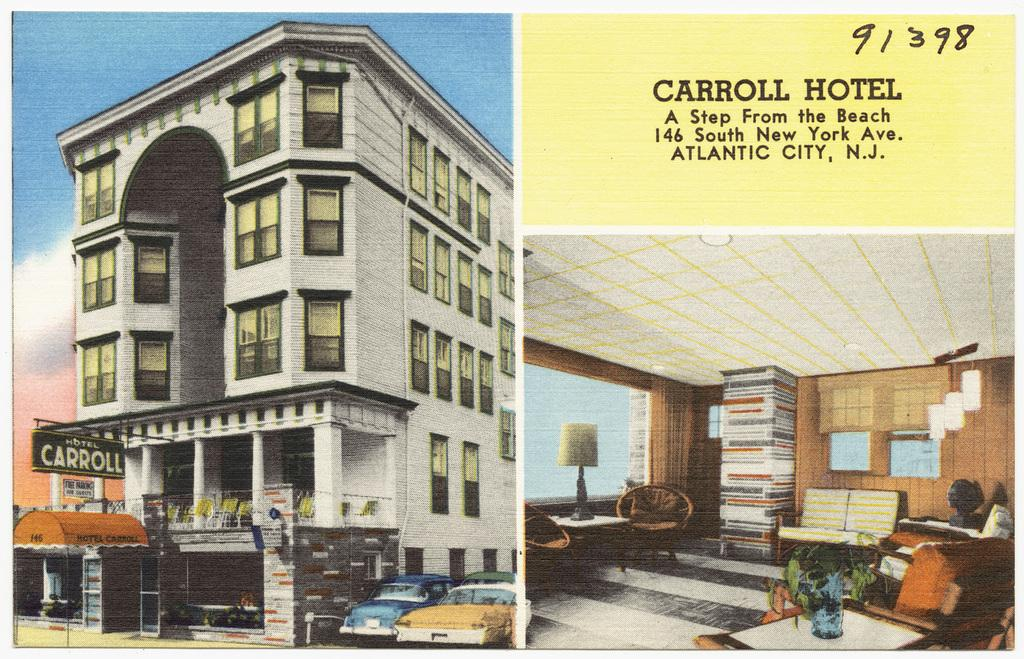<image>
Describe the image concisely. The outside of the Caroll Hotel is shown on this postcard, that shows the address for the hotel that is a "step from the beach" in Atlantic City NJ. 